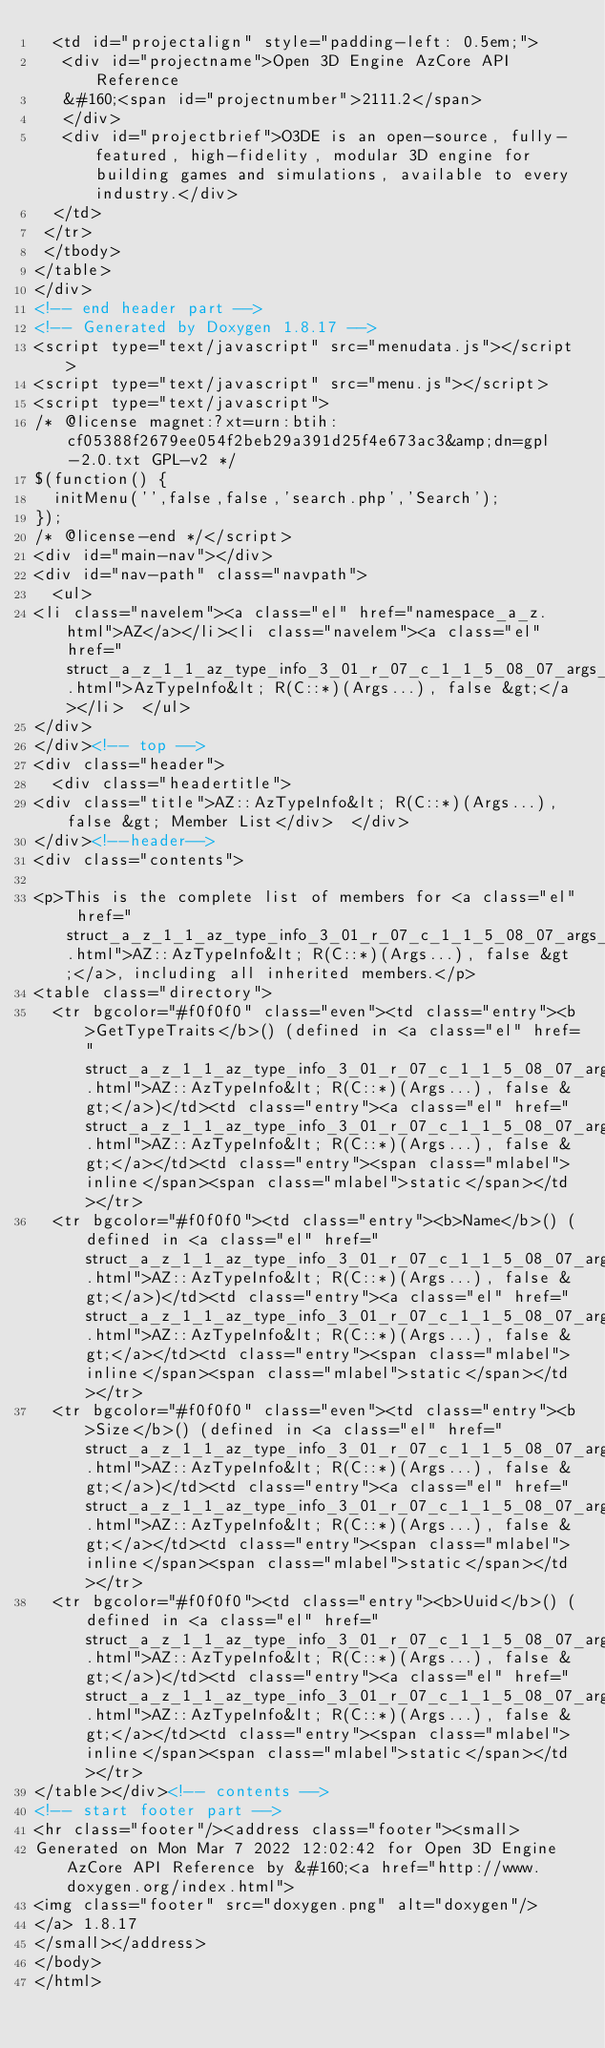<code> <loc_0><loc_0><loc_500><loc_500><_HTML_>  <td id="projectalign" style="padding-left: 0.5em;">
   <div id="projectname">Open 3D Engine AzCore API Reference
   &#160;<span id="projectnumber">2111.2</span>
   </div>
   <div id="projectbrief">O3DE is an open-source, fully-featured, high-fidelity, modular 3D engine for building games and simulations, available to every industry.</div>
  </td>
 </tr>
 </tbody>
</table>
</div>
<!-- end header part -->
<!-- Generated by Doxygen 1.8.17 -->
<script type="text/javascript" src="menudata.js"></script>
<script type="text/javascript" src="menu.js"></script>
<script type="text/javascript">
/* @license magnet:?xt=urn:btih:cf05388f2679ee054f2beb29a391d25f4e673ac3&amp;dn=gpl-2.0.txt GPL-v2 */
$(function() {
  initMenu('',false,false,'search.php','Search');
});
/* @license-end */</script>
<div id="main-nav"></div>
<div id="nav-path" class="navpath">
  <ul>
<li class="navelem"><a class="el" href="namespace_a_z.html">AZ</a></li><li class="navelem"><a class="el" href="struct_a_z_1_1_az_type_info_3_01_r_07_c_1_1_5_08_07_args_8_8_8_08_00_01false_01_4.html">AzTypeInfo&lt; R(C::*)(Args...), false &gt;</a></li>  </ul>
</div>
</div><!-- top -->
<div class="header">
  <div class="headertitle">
<div class="title">AZ::AzTypeInfo&lt; R(C::*)(Args...), false &gt; Member List</div>  </div>
</div><!--header-->
<div class="contents">

<p>This is the complete list of members for <a class="el" href="struct_a_z_1_1_az_type_info_3_01_r_07_c_1_1_5_08_07_args_8_8_8_08_00_01false_01_4.html">AZ::AzTypeInfo&lt; R(C::*)(Args...), false &gt;</a>, including all inherited members.</p>
<table class="directory">
  <tr bgcolor="#f0f0f0" class="even"><td class="entry"><b>GetTypeTraits</b>() (defined in <a class="el" href="struct_a_z_1_1_az_type_info_3_01_r_07_c_1_1_5_08_07_args_8_8_8_08_00_01false_01_4.html">AZ::AzTypeInfo&lt; R(C::*)(Args...), false &gt;</a>)</td><td class="entry"><a class="el" href="struct_a_z_1_1_az_type_info_3_01_r_07_c_1_1_5_08_07_args_8_8_8_08_00_01false_01_4.html">AZ::AzTypeInfo&lt; R(C::*)(Args...), false &gt;</a></td><td class="entry"><span class="mlabel">inline</span><span class="mlabel">static</span></td></tr>
  <tr bgcolor="#f0f0f0"><td class="entry"><b>Name</b>() (defined in <a class="el" href="struct_a_z_1_1_az_type_info_3_01_r_07_c_1_1_5_08_07_args_8_8_8_08_00_01false_01_4.html">AZ::AzTypeInfo&lt; R(C::*)(Args...), false &gt;</a>)</td><td class="entry"><a class="el" href="struct_a_z_1_1_az_type_info_3_01_r_07_c_1_1_5_08_07_args_8_8_8_08_00_01false_01_4.html">AZ::AzTypeInfo&lt; R(C::*)(Args...), false &gt;</a></td><td class="entry"><span class="mlabel">inline</span><span class="mlabel">static</span></td></tr>
  <tr bgcolor="#f0f0f0" class="even"><td class="entry"><b>Size</b>() (defined in <a class="el" href="struct_a_z_1_1_az_type_info_3_01_r_07_c_1_1_5_08_07_args_8_8_8_08_00_01false_01_4.html">AZ::AzTypeInfo&lt; R(C::*)(Args...), false &gt;</a>)</td><td class="entry"><a class="el" href="struct_a_z_1_1_az_type_info_3_01_r_07_c_1_1_5_08_07_args_8_8_8_08_00_01false_01_4.html">AZ::AzTypeInfo&lt; R(C::*)(Args...), false &gt;</a></td><td class="entry"><span class="mlabel">inline</span><span class="mlabel">static</span></td></tr>
  <tr bgcolor="#f0f0f0"><td class="entry"><b>Uuid</b>() (defined in <a class="el" href="struct_a_z_1_1_az_type_info_3_01_r_07_c_1_1_5_08_07_args_8_8_8_08_00_01false_01_4.html">AZ::AzTypeInfo&lt; R(C::*)(Args...), false &gt;</a>)</td><td class="entry"><a class="el" href="struct_a_z_1_1_az_type_info_3_01_r_07_c_1_1_5_08_07_args_8_8_8_08_00_01false_01_4.html">AZ::AzTypeInfo&lt; R(C::*)(Args...), false &gt;</a></td><td class="entry"><span class="mlabel">inline</span><span class="mlabel">static</span></td></tr>
</table></div><!-- contents -->
<!-- start footer part -->
<hr class="footer"/><address class="footer"><small>
Generated on Mon Mar 7 2022 12:02:42 for Open 3D Engine AzCore API Reference by &#160;<a href="http://www.doxygen.org/index.html">
<img class="footer" src="doxygen.png" alt="doxygen"/>
</a> 1.8.17
</small></address>
</body>
</html>
</code> 